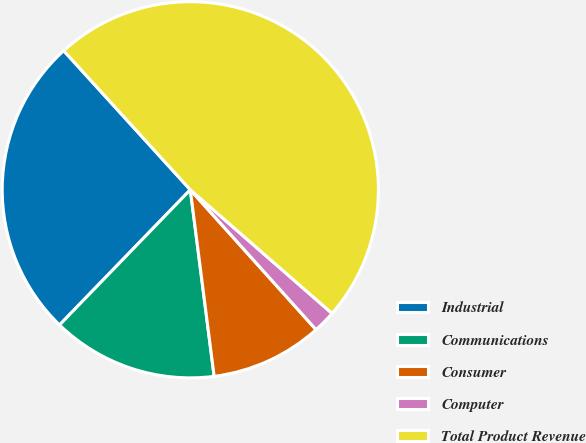Convert chart to OTSL. <chart><loc_0><loc_0><loc_500><loc_500><pie_chart><fcel>Industrial<fcel>Communications<fcel>Consumer<fcel>Computer<fcel>Total Product Revenue<nl><fcel>26.01%<fcel>14.26%<fcel>9.63%<fcel>1.93%<fcel>48.17%<nl></chart> 